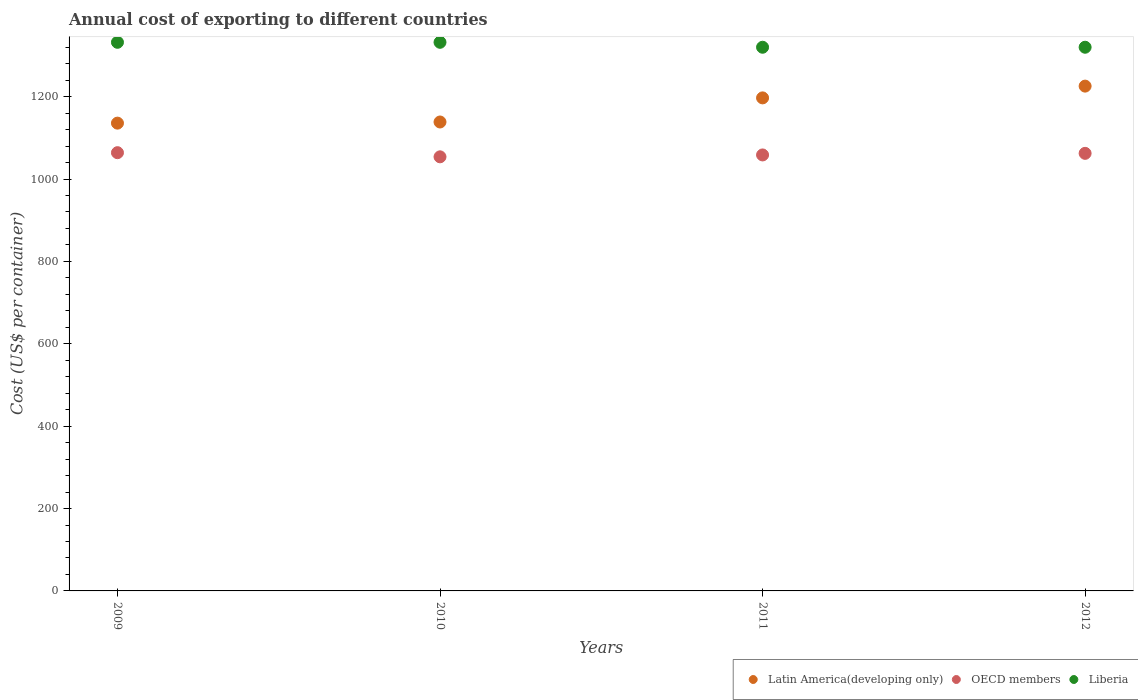How many different coloured dotlines are there?
Make the answer very short. 3. Is the number of dotlines equal to the number of legend labels?
Make the answer very short. Yes. What is the total annual cost of exporting in Latin America(developing only) in 2012?
Provide a succinct answer. 1225.61. Across all years, what is the maximum total annual cost of exporting in Liberia?
Keep it short and to the point. 1332. Across all years, what is the minimum total annual cost of exporting in OECD members?
Give a very brief answer. 1053.94. In which year was the total annual cost of exporting in Liberia minimum?
Give a very brief answer. 2011. What is the total total annual cost of exporting in Liberia in the graph?
Offer a terse response. 5304. What is the difference between the total annual cost of exporting in OECD members in 2010 and that in 2011?
Offer a terse response. -4.59. What is the difference between the total annual cost of exporting in Liberia in 2011 and the total annual cost of exporting in OECD members in 2010?
Provide a short and direct response. 266.06. What is the average total annual cost of exporting in OECD members per year?
Your answer should be compact. 1059.71. In the year 2011, what is the difference between the total annual cost of exporting in OECD members and total annual cost of exporting in Liberia?
Your answer should be compact. -261.47. In how many years, is the total annual cost of exporting in OECD members greater than 440 US$?
Your answer should be compact. 4. What is the ratio of the total annual cost of exporting in OECD members in 2009 to that in 2010?
Make the answer very short. 1.01. Is the total annual cost of exporting in Liberia in 2009 less than that in 2010?
Give a very brief answer. No. Is the difference between the total annual cost of exporting in OECD members in 2009 and 2010 greater than the difference between the total annual cost of exporting in Liberia in 2009 and 2010?
Offer a very short reply. Yes. What is the difference between the highest and the second highest total annual cost of exporting in Latin America(developing only)?
Your answer should be compact. 28.57. What is the difference between the highest and the lowest total annual cost of exporting in Liberia?
Offer a very short reply. 12. Is it the case that in every year, the sum of the total annual cost of exporting in OECD members and total annual cost of exporting in Latin America(developing only)  is greater than the total annual cost of exporting in Liberia?
Offer a terse response. Yes. Is the total annual cost of exporting in Latin America(developing only) strictly greater than the total annual cost of exporting in Liberia over the years?
Your answer should be very brief. No. Are the values on the major ticks of Y-axis written in scientific E-notation?
Your answer should be very brief. No. Does the graph contain any zero values?
Your answer should be compact. No. Where does the legend appear in the graph?
Your answer should be compact. Bottom right. How are the legend labels stacked?
Offer a very short reply. Horizontal. What is the title of the graph?
Your response must be concise. Annual cost of exporting to different countries. What is the label or title of the Y-axis?
Make the answer very short. Cost (US$ per container). What is the Cost (US$ per container) of Latin America(developing only) in 2009?
Your answer should be very brief. 1135.74. What is the Cost (US$ per container) of OECD members in 2009?
Your response must be concise. 1064. What is the Cost (US$ per container) in Liberia in 2009?
Ensure brevity in your answer.  1332. What is the Cost (US$ per container) in Latin America(developing only) in 2010?
Make the answer very short. 1138.52. What is the Cost (US$ per container) of OECD members in 2010?
Make the answer very short. 1053.94. What is the Cost (US$ per container) in Liberia in 2010?
Offer a very short reply. 1332. What is the Cost (US$ per container) of Latin America(developing only) in 2011?
Your answer should be compact. 1197.04. What is the Cost (US$ per container) in OECD members in 2011?
Make the answer very short. 1058.53. What is the Cost (US$ per container) in Liberia in 2011?
Make the answer very short. 1320. What is the Cost (US$ per container) in Latin America(developing only) in 2012?
Make the answer very short. 1225.61. What is the Cost (US$ per container) in OECD members in 2012?
Give a very brief answer. 1062.38. What is the Cost (US$ per container) of Liberia in 2012?
Offer a terse response. 1320. Across all years, what is the maximum Cost (US$ per container) in Latin America(developing only)?
Provide a short and direct response. 1225.61. Across all years, what is the maximum Cost (US$ per container) of OECD members?
Provide a short and direct response. 1064. Across all years, what is the maximum Cost (US$ per container) of Liberia?
Offer a terse response. 1332. Across all years, what is the minimum Cost (US$ per container) of Latin America(developing only)?
Your response must be concise. 1135.74. Across all years, what is the minimum Cost (US$ per container) of OECD members?
Provide a short and direct response. 1053.94. Across all years, what is the minimum Cost (US$ per container) of Liberia?
Provide a succinct answer. 1320. What is the total Cost (US$ per container) in Latin America(developing only) in the graph?
Ensure brevity in your answer.  4696.91. What is the total Cost (US$ per container) of OECD members in the graph?
Keep it short and to the point. 4238.85. What is the total Cost (US$ per container) of Liberia in the graph?
Your response must be concise. 5304. What is the difference between the Cost (US$ per container) of Latin America(developing only) in 2009 and that in 2010?
Provide a succinct answer. -2.78. What is the difference between the Cost (US$ per container) in OECD members in 2009 and that in 2010?
Provide a short and direct response. 10.06. What is the difference between the Cost (US$ per container) of Liberia in 2009 and that in 2010?
Provide a succinct answer. 0. What is the difference between the Cost (US$ per container) in Latin America(developing only) in 2009 and that in 2011?
Keep it short and to the point. -61.3. What is the difference between the Cost (US$ per container) of OECD members in 2009 and that in 2011?
Your answer should be compact. 5.47. What is the difference between the Cost (US$ per container) in Latin America(developing only) in 2009 and that in 2012?
Offer a very short reply. -89.87. What is the difference between the Cost (US$ per container) of OECD members in 2009 and that in 2012?
Ensure brevity in your answer.  1.62. What is the difference between the Cost (US$ per container) in Liberia in 2009 and that in 2012?
Provide a short and direct response. 12. What is the difference between the Cost (US$ per container) of Latin America(developing only) in 2010 and that in 2011?
Your response must be concise. -58.52. What is the difference between the Cost (US$ per container) in OECD members in 2010 and that in 2011?
Provide a succinct answer. -4.59. What is the difference between the Cost (US$ per container) in Latin America(developing only) in 2010 and that in 2012?
Ensure brevity in your answer.  -87.09. What is the difference between the Cost (US$ per container) of OECD members in 2010 and that in 2012?
Offer a very short reply. -8.44. What is the difference between the Cost (US$ per container) in Liberia in 2010 and that in 2012?
Offer a very short reply. 12. What is the difference between the Cost (US$ per container) of Latin America(developing only) in 2011 and that in 2012?
Provide a succinct answer. -28.57. What is the difference between the Cost (US$ per container) of OECD members in 2011 and that in 2012?
Keep it short and to the point. -3.85. What is the difference between the Cost (US$ per container) of Latin America(developing only) in 2009 and the Cost (US$ per container) of OECD members in 2010?
Provide a short and direct response. 81.8. What is the difference between the Cost (US$ per container) of Latin America(developing only) in 2009 and the Cost (US$ per container) of Liberia in 2010?
Offer a very short reply. -196.26. What is the difference between the Cost (US$ per container) of OECD members in 2009 and the Cost (US$ per container) of Liberia in 2010?
Provide a short and direct response. -268. What is the difference between the Cost (US$ per container) in Latin America(developing only) in 2009 and the Cost (US$ per container) in OECD members in 2011?
Provide a short and direct response. 77.21. What is the difference between the Cost (US$ per container) of Latin America(developing only) in 2009 and the Cost (US$ per container) of Liberia in 2011?
Give a very brief answer. -184.26. What is the difference between the Cost (US$ per container) of OECD members in 2009 and the Cost (US$ per container) of Liberia in 2011?
Ensure brevity in your answer.  -256. What is the difference between the Cost (US$ per container) of Latin America(developing only) in 2009 and the Cost (US$ per container) of OECD members in 2012?
Make the answer very short. 73.36. What is the difference between the Cost (US$ per container) in Latin America(developing only) in 2009 and the Cost (US$ per container) in Liberia in 2012?
Make the answer very short. -184.26. What is the difference between the Cost (US$ per container) of OECD members in 2009 and the Cost (US$ per container) of Liberia in 2012?
Keep it short and to the point. -256. What is the difference between the Cost (US$ per container) of Latin America(developing only) in 2010 and the Cost (US$ per container) of OECD members in 2011?
Your response must be concise. 79.99. What is the difference between the Cost (US$ per container) in Latin America(developing only) in 2010 and the Cost (US$ per container) in Liberia in 2011?
Provide a short and direct response. -181.48. What is the difference between the Cost (US$ per container) in OECD members in 2010 and the Cost (US$ per container) in Liberia in 2011?
Provide a short and direct response. -266.06. What is the difference between the Cost (US$ per container) of Latin America(developing only) in 2010 and the Cost (US$ per container) of OECD members in 2012?
Your answer should be compact. 76.14. What is the difference between the Cost (US$ per container) of Latin America(developing only) in 2010 and the Cost (US$ per container) of Liberia in 2012?
Your response must be concise. -181.48. What is the difference between the Cost (US$ per container) in OECD members in 2010 and the Cost (US$ per container) in Liberia in 2012?
Offer a very short reply. -266.06. What is the difference between the Cost (US$ per container) of Latin America(developing only) in 2011 and the Cost (US$ per container) of OECD members in 2012?
Provide a succinct answer. 134.66. What is the difference between the Cost (US$ per container) of Latin America(developing only) in 2011 and the Cost (US$ per container) of Liberia in 2012?
Give a very brief answer. -122.96. What is the difference between the Cost (US$ per container) in OECD members in 2011 and the Cost (US$ per container) in Liberia in 2012?
Your response must be concise. -261.47. What is the average Cost (US$ per container) in Latin America(developing only) per year?
Offer a terse response. 1174.23. What is the average Cost (US$ per container) in OECD members per year?
Give a very brief answer. 1059.71. What is the average Cost (US$ per container) in Liberia per year?
Your response must be concise. 1326. In the year 2009, what is the difference between the Cost (US$ per container) in Latin America(developing only) and Cost (US$ per container) in OECD members?
Keep it short and to the point. 71.74. In the year 2009, what is the difference between the Cost (US$ per container) of Latin America(developing only) and Cost (US$ per container) of Liberia?
Your answer should be very brief. -196.26. In the year 2009, what is the difference between the Cost (US$ per container) of OECD members and Cost (US$ per container) of Liberia?
Your answer should be very brief. -268. In the year 2010, what is the difference between the Cost (US$ per container) of Latin America(developing only) and Cost (US$ per container) of OECD members?
Ensure brevity in your answer.  84.58. In the year 2010, what is the difference between the Cost (US$ per container) of Latin America(developing only) and Cost (US$ per container) of Liberia?
Make the answer very short. -193.48. In the year 2010, what is the difference between the Cost (US$ per container) of OECD members and Cost (US$ per container) of Liberia?
Offer a very short reply. -278.06. In the year 2011, what is the difference between the Cost (US$ per container) of Latin America(developing only) and Cost (US$ per container) of OECD members?
Ensure brevity in your answer.  138.51. In the year 2011, what is the difference between the Cost (US$ per container) of Latin America(developing only) and Cost (US$ per container) of Liberia?
Make the answer very short. -122.96. In the year 2011, what is the difference between the Cost (US$ per container) of OECD members and Cost (US$ per container) of Liberia?
Provide a short and direct response. -261.47. In the year 2012, what is the difference between the Cost (US$ per container) of Latin America(developing only) and Cost (US$ per container) of OECD members?
Keep it short and to the point. 163.23. In the year 2012, what is the difference between the Cost (US$ per container) of Latin America(developing only) and Cost (US$ per container) of Liberia?
Provide a short and direct response. -94.39. In the year 2012, what is the difference between the Cost (US$ per container) in OECD members and Cost (US$ per container) in Liberia?
Your answer should be compact. -257.62. What is the ratio of the Cost (US$ per container) of OECD members in 2009 to that in 2010?
Provide a short and direct response. 1.01. What is the ratio of the Cost (US$ per container) in Latin America(developing only) in 2009 to that in 2011?
Keep it short and to the point. 0.95. What is the ratio of the Cost (US$ per container) of OECD members in 2009 to that in 2011?
Offer a very short reply. 1.01. What is the ratio of the Cost (US$ per container) of Liberia in 2009 to that in 2011?
Your answer should be very brief. 1.01. What is the ratio of the Cost (US$ per container) in Latin America(developing only) in 2009 to that in 2012?
Provide a succinct answer. 0.93. What is the ratio of the Cost (US$ per container) of OECD members in 2009 to that in 2012?
Provide a succinct answer. 1. What is the ratio of the Cost (US$ per container) of Liberia in 2009 to that in 2012?
Your answer should be compact. 1.01. What is the ratio of the Cost (US$ per container) of Latin America(developing only) in 2010 to that in 2011?
Your answer should be compact. 0.95. What is the ratio of the Cost (US$ per container) of OECD members in 2010 to that in 2011?
Provide a short and direct response. 1. What is the ratio of the Cost (US$ per container) in Liberia in 2010 to that in 2011?
Your response must be concise. 1.01. What is the ratio of the Cost (US$ per container) in Latin America(developing only) in 2010 to that in 2012?
Offer a very short reply. 0.93. What is the ratio of the Cost (US$ per container) in OECD members in 2010 to that in 2012?
Offer a terse response. 0.99. What is the ratio of the Cost (US$ per container) in Liberia in 2010 to that in 2012?
Offer a very short reply. 1.01. What is the ratio of the Cost (US$ per container) of Latin America(developing only) in 2011 to that in 2012?
Your answer should be very brief. 0.98. What is the ratio of the Cost (US$ per container) in OECD members in 2011 to that in 2012?
Make the answer very short. 1. What is the difference between the highest and the second highest Cost (US$ per container) in Latin America(developing only)?
Keep it short and to the point. 28.57. What is the difference between the highest and the second highest Cost (US$ per container) in OECD members?
Make the answer very short. 1.62. What is the difference between the highest and the second highest Cost (US$ per container) of Liberia?
Your answer should be very brief. 0. What is the difference between the highest and the lowest Cost (US$ per container) in Latin America(developing only)?
Provide a succinct answer. 89.87. What is the difference between the highest and the lowest Cost (US$ per container) of OECD members?
Give a very brief answer. 10.06. 